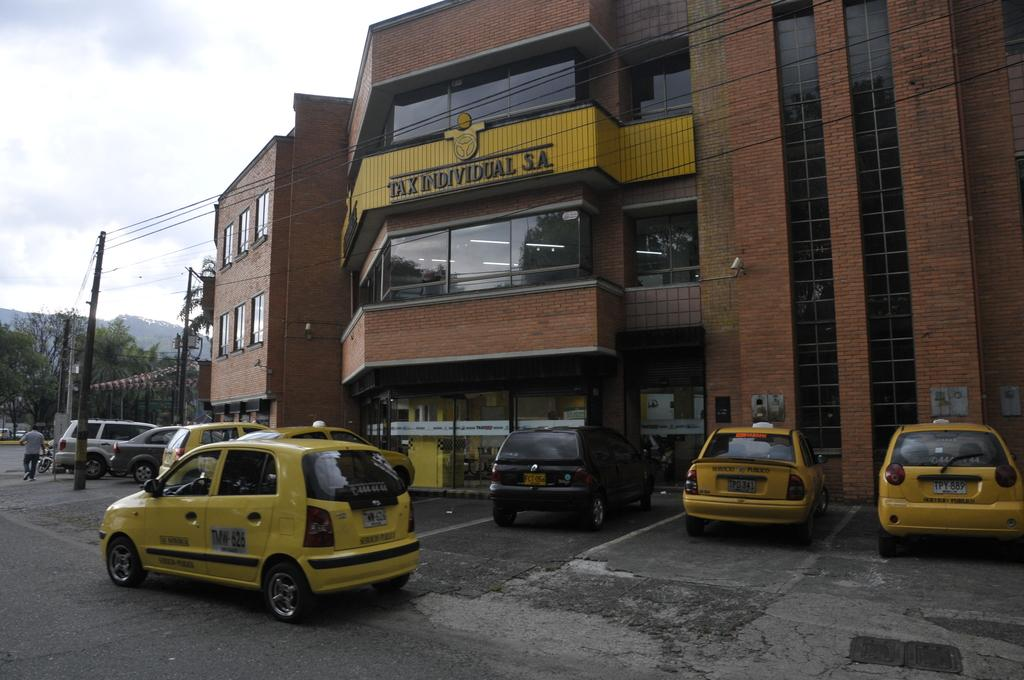What can be seen in large numbers in the image? There are many vehicles in the image. What type of structure is present in the image? There is a building with windows in the image. What is the name of the building? The building has a name. What can be seen in the background of the image? There are trees and electric poles with wires in the background of the image. What is visible at the top of the image? The sky is visible in the image. What type of quartz can be seen in the image? There is no quartz present in the image. Can you see any magical elements in the image? There are no magical elements present in the image. 